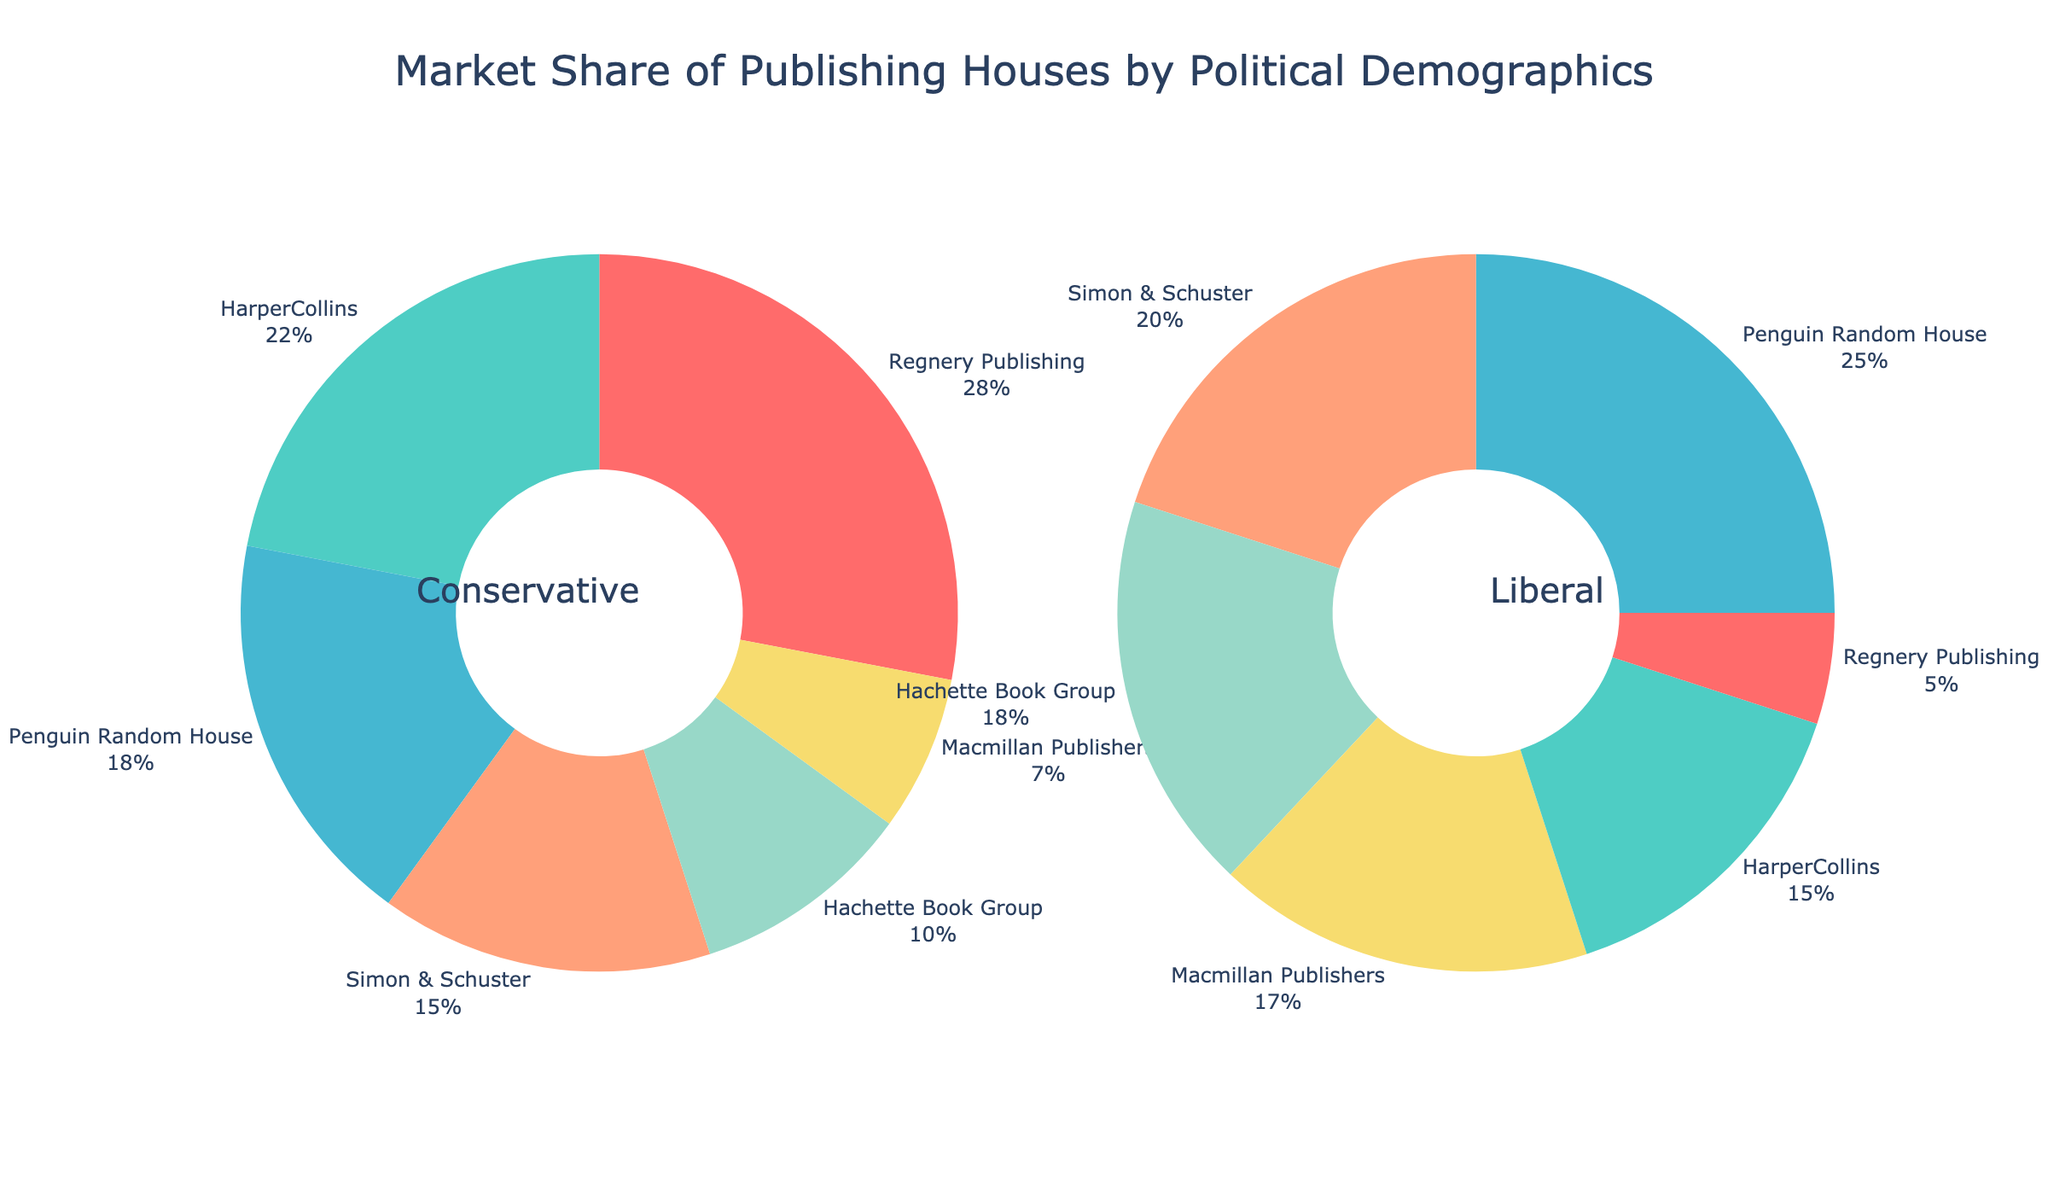What's the title of the figure? The title of the figure is positioned at the top and centrally aligned. It reads "Market Share of Publishing Houses by Political Demographics".
Answer: Market Share of Publishing Houses by Political Demographics Which publishing house has the highest conservative market share? In the conservative market share pie chart, looking at the names and percentages, Regnery Publishing has the highest share at 28%.
Answer: Regnery Publishing What percentage of the market does Penguin Random House hold among liberals? In the liberal market share pie chart, referencing the segments, Penguin Random House holds a 25% share among liberals.
Answer: 25% How does the market share of HarperCollins compare between conservatives and liberals? Comparing the percentages in both pie charts, HarperCollins has a 22% share among conservatives and a 15% share among liberals.
Answer: 22% vs. 15% Which publishing house shows the smallest share in the conservative market? In the conservative market share pie chart, the smallest segment belongs to Macmillan Publishers with a 7% share.
Answer: Macmillan Publishers If we combine the market shares of Simon & Schuster and Hachette Book Group for liberals, what is their total market share? From the liberal market share pie chart, Simon & Schuster holds 20% and Hachette Book Group holds 18%. Together, their combined share is 20% + 18% = 38%.
Answer: 38% Between conservatives and liberals, which demographic sees a larger market share for Simon & Schuster? By comparing both charts, Simon & Schuster has 15% in the conservative market and 20% in the liberal market. Thus, it has a larger share among liberals.
Answer: Liberals What is the difference in market share for Penguin Random House between conservatives and liberals? Penguin Random House holds 18% in the conservative market and 25% in the liberal market. The difference is 25% - 18% = 7%.
Answer: 7% Which two publishing houses have the closest market shares among liberals? In the liberal market share pie chart, HarperCollins and Macmillan Publishers have shares of 15% and 17%, respectively. These are the closest shares.
Answer: HarperCollins and Macmillan Publishers What's the total percentage of the conservative market held by HarperCollins, Penguin Random House, and Simon & Schuster combined? The conservative market shares for HarperCollins, Penguin Random House, and Simon & Schuster are 22%, 18%, and 15% respectively. Their combined share is 22% + 18% + 15% = 55%.
Answer: 55% 